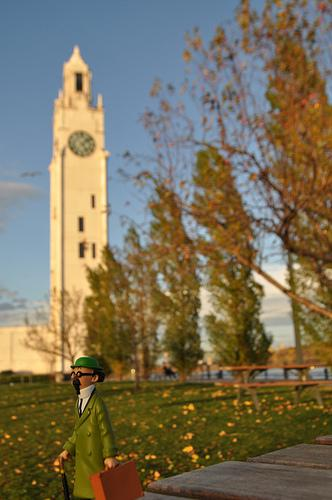Question: what is the animated person wearing on their head?
Choices:
A. Tobogan.
B. Books.
C. Pitcher.
D. A hat.
Answer with the letter. Answer: D Question: how many clock towers are in this photo?
Choices:
A. Two.
B. None.
C. One.
D. Four.
Answer with the letter. Answer: C 